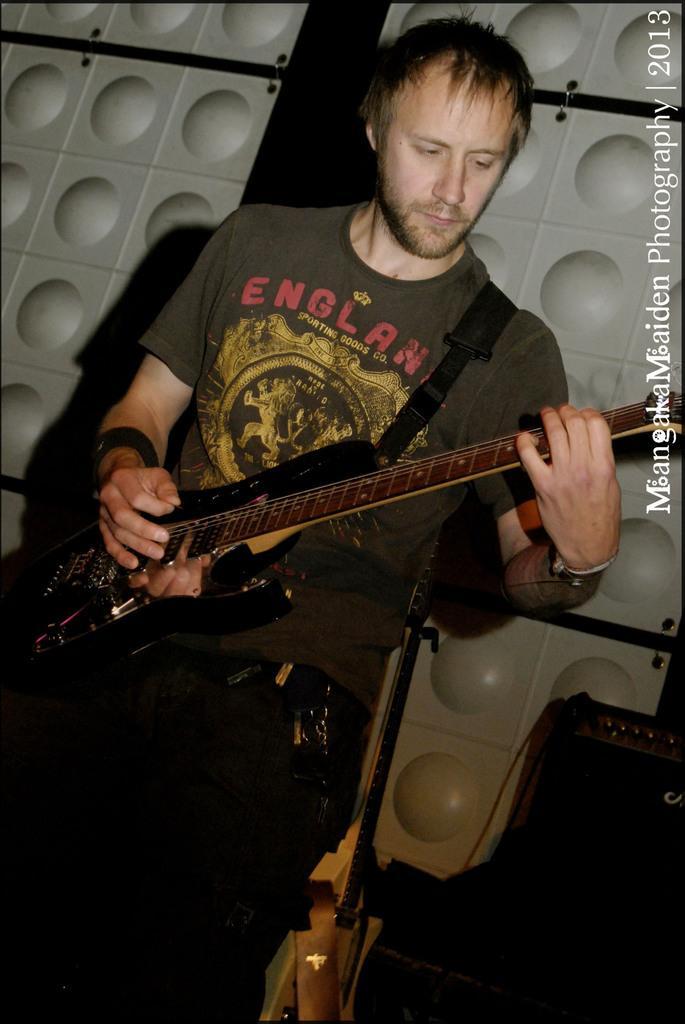Could you give a brief overview of what you see in this image? In this image there is a man playing guitar, in the background there is a wall on the top right there is some text. 